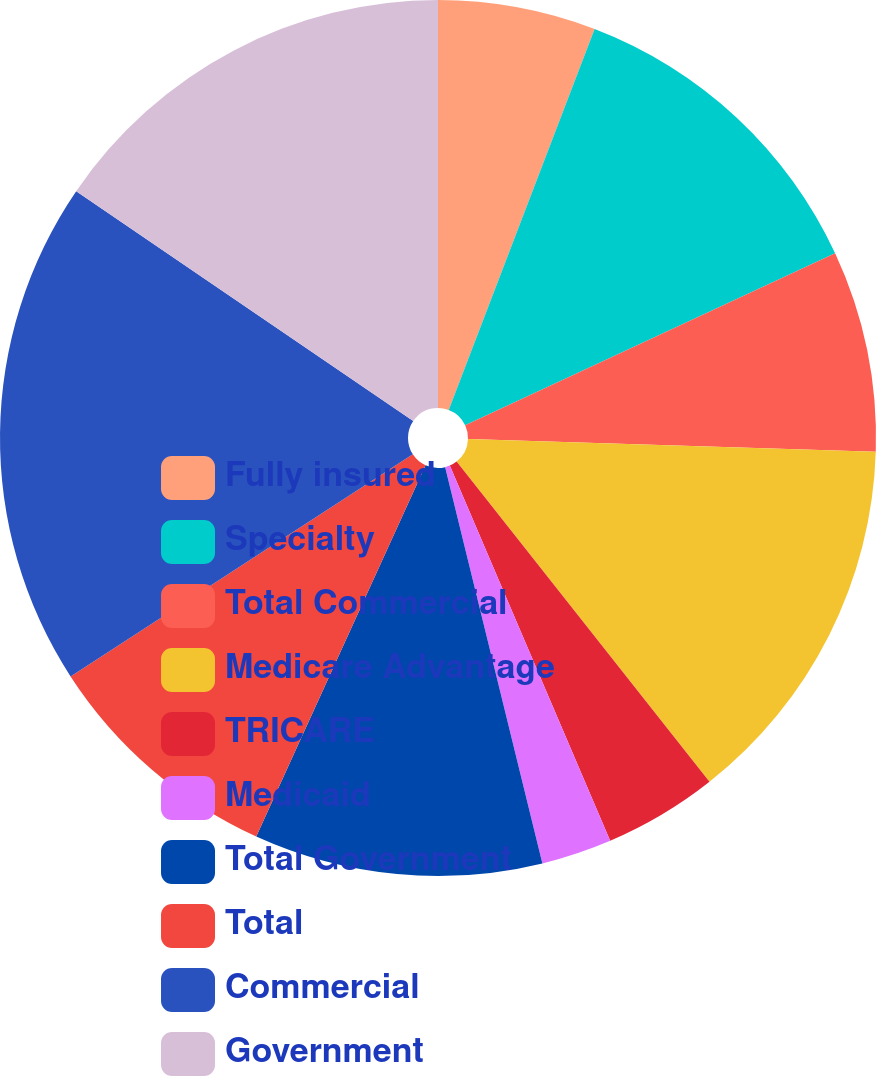<chart> <loc_0><loc_0><loc_500><loc_500><pie_chart><fcel>Fully insured<fcel>Specialty<fcel>Total Commercial<fcel>Medicare Advantage<fcel>TRICARE<fcel>Medicaid<fcel>Total Government<fcel>Total<fcel>Commercial<fcel>Government<nl><fcel>5.82%<fcel>12.25%<fcel>7.43%<fcel>13.86%<fcel>4.21%<fcel>2.6%<fcel>10.64%<fcel>9.03%<fcel>18.69%<fcel>15.47%<nl></chart> 